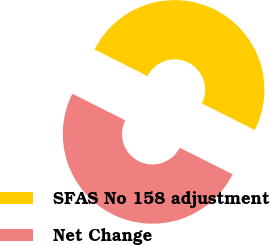<chart> <loc_0><loc_0><loc_500><loc_500><pie_chart><fcel>SFAS No 158 adjustment<fcel>Net Change<nl><fcel>49.99%<fcel>50.01%<nl></chart> 